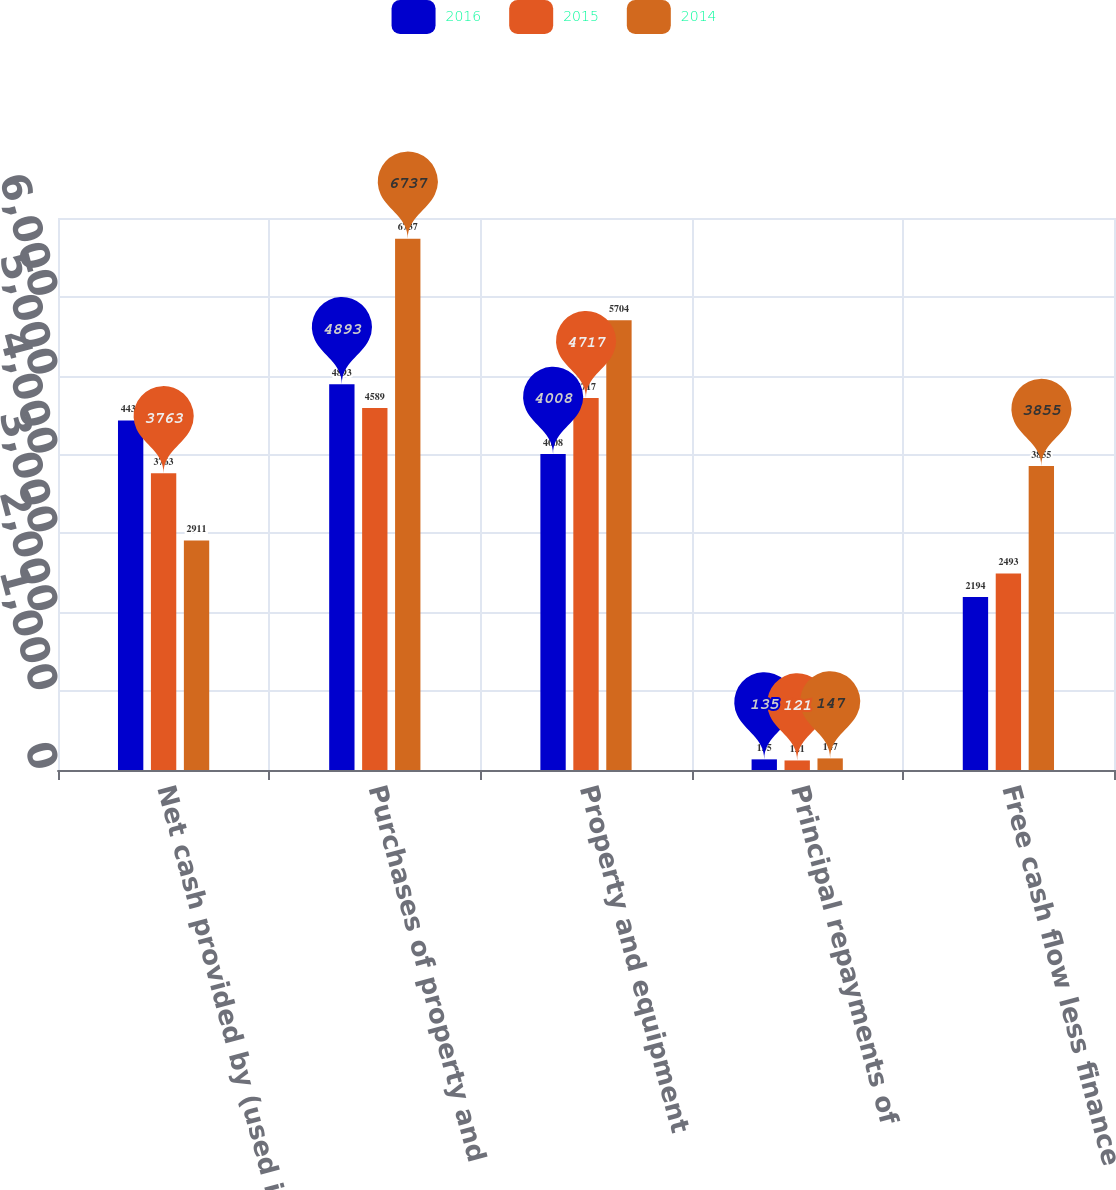Convert chart. <chart><loc_0><loc_0><loc_500><loc_500><stacked_bar_chart><ecel><fcel>Net cash provided by (used in)<fcel>Purchases of property and<fcel>Property and equipment<fcel>Principal repayments of<fcel>Free cash flow less finance<nl><fcel>2016<fcel>4432<fcel>4893<fcel>4008<fcel>135<fcel>2194<nl><fcel>2015<fcel>3763<fcel>4589<fcel>4717<fcel>121<fcel>2493<nl><fcel>2014<fcel>2911<fcel>6737<fcel>5704<fcel>147<fcel>3855<nl></chart> 